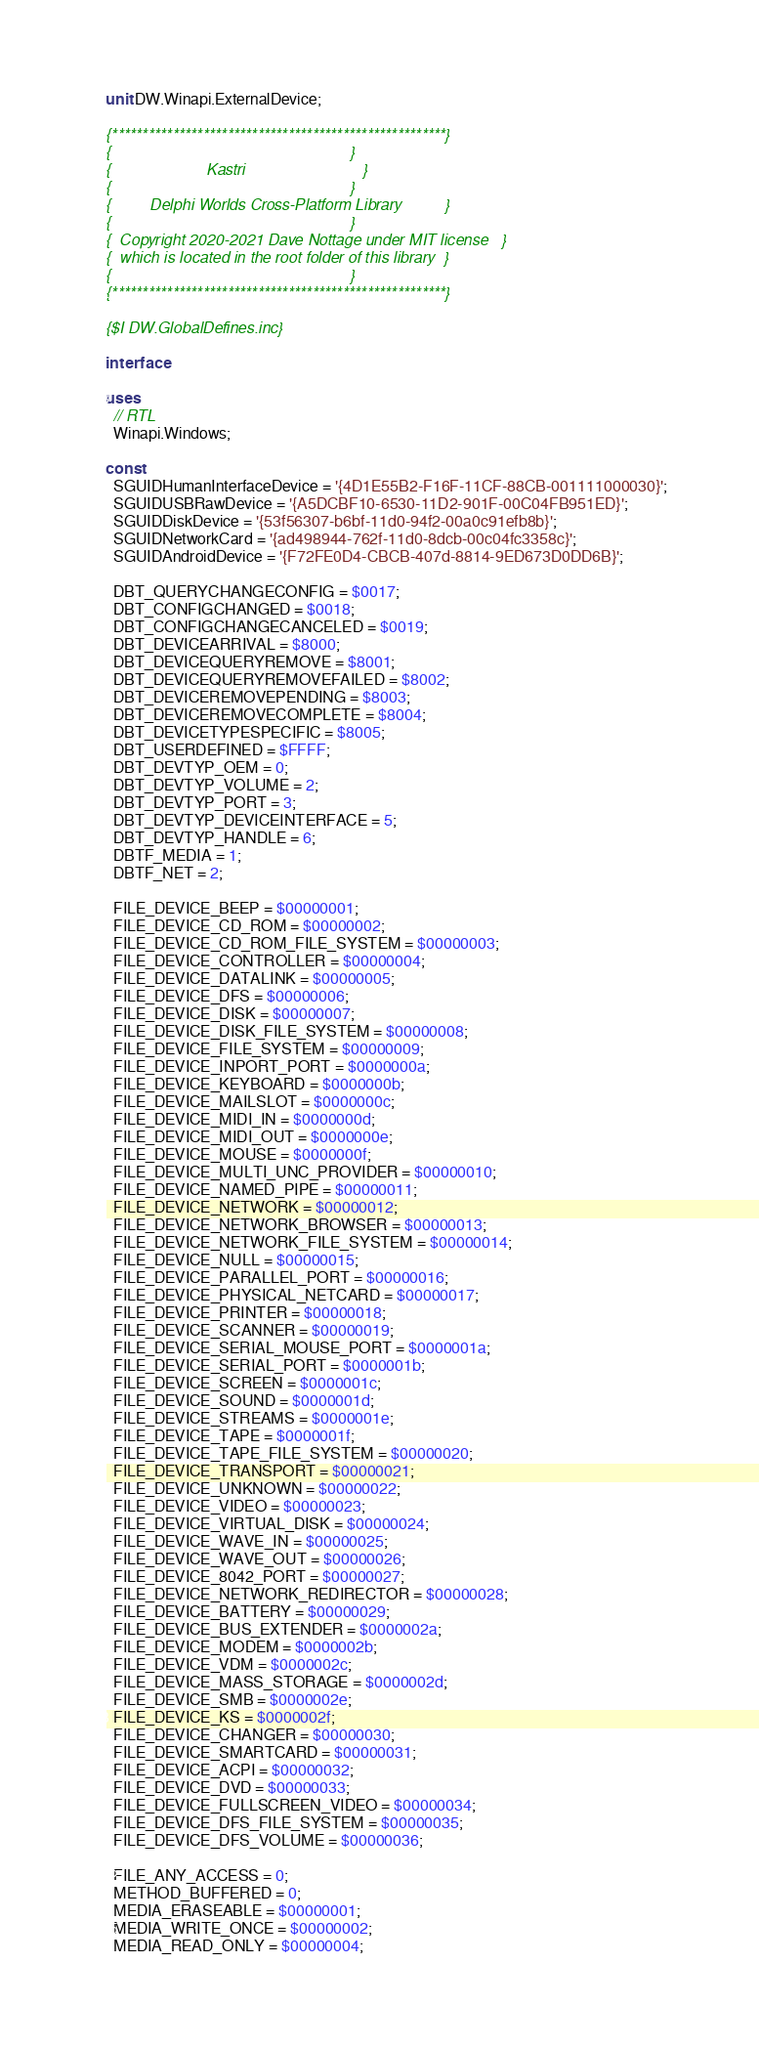<code> <loc_0><loc_0><loc_500><loc_500><_Pascal_>unit DW.Winapi.ExternalDevice;

{*******************************************************}
{                                                       }
{                      Kastri                           }
{                                                       }
{         Delphi Worlds Cross-Platform Library          }
{                                                       }
{  Copyright 2020-2021 Dave Nottage under MIT license   }
{  which is located in the root folder of this library  }
{                                                       }
{*******************************************************}

{$I DW.GlobalDefines.inc}

interface

uses
  // RTL
  Winapi.Windows;

const
  SGUIDHumanInterfaceDevice = '{4D1E55B2-F16F-11CF-88CB-001111000030}';
  SGUIDUSBRawDevice = '{A5DCBF10-6530-11D2-901F-00C04FB951ED}';
  SGUIDDiskDevice = '{53f56307-b6bf-11d0-94f2-00a0c91efb8b}';
  SGUIDNetworkCard = '{ad498944-762f-11d0-8dcb-00c04fc3358c}';
  SGUIDAndroidDevice = '{F72FE0D4-CBCB-407d-8814-9ED673D0DD6B}';

  DBT_QUERYCHANGECONFIG = $0017;
  DBT_CONFIGCHANGED = $0018;
  DBT_CONFIGCHANGECANCELED = $0019;
  DBT_DEVICEARRIVAL = $8000;
  DBT_DEVICEQUERYREMOVE = $8001;
  DBT_DEVICEQUERYREMOVEFAILED = $8002;
  DBT_DEVICEREMOVEPENDING = $8003;
  DBT_DEVICEREMOVECOMPLETE = $8004;
  DBT_DEVICETYPESPECIFIC = $8005;
  DBT_USERDEFINED = $FFFF;
  DBT_DEVTYP_OEM = 0;
  DBT_DEVTYP_VOLUME = 2;
  DBT_DEVTYP_PORT = 3;
  DBT_DEVTYP_DEVICEINTERFACE = 5;
  DBT_DEVTYP_HANDLE = 6;
  DBTF_MEDIA = 1;
  DBTF_NET = 2;

  FILE_DEVICE_BEEP = $00000001;
  FILE_DEVICE_CD_ROM = $00000002;
  FILE_DEVICE_CD_ROM_FILE_SYSTEM = $00000003;
  FILE_DEVICE_CONTROLLER = $00000004;
  FILE_DEVICE_DATALINK = $00000005;
  FILE_DEVICE_DFS = $00000006;
  FILE_DEVICE_DISK = $00000007;
  FILE_DEVICE_DISK_FILE_SYSTEM = $00000008;
  FILE_DEVICE_FILE_SYSTEM = $00000009;
  FILE_DEVICE_INPORT_PORT = $0000000a;
  FILE_DEVICE_KEYBOARD = $0000000b;
  FILE_DEVICE_MAILSLOT = $0000000c;
  FILE_DEVICE_MIDI_IN = $0000000d;
  FILE_DEVICE_MIDI_OUT = $0000000e;
  FILE_DEVICE_MOUSE = $0000000f;
  FILE_DEVICE_MULTI_UNC_PROVIDER = $00000010;
  FILE_DEVICE_NAMED_PIPE = $00000011;
  FILE_DEVICE_NETWORK = $00000012;
  FILE_DEVICE_NETWORK_BROWSER = $00000013;
  FILE_DEVICE_NETWORK_FILE_SYSTEM = $00000014;
  FILE_DEVICE_NULL = $00000015;
  FILE_DEVICE_PARALLEL_PORT = $00000016;
  FILE_DEVICE_PHYSICAL_NETCARD = $00000017;
  FILE_DEVICE_PRINTER = $00000018;
  FILE_DEVICE_SCANNER = $00000019;
  FILE_DEVICE_SERIAL_MOUSE_PORT = $0000001a;
  FILE_DEVICE_SERIAL_PORT = $0000001b;
  FILE_DEVICE_SCREEN = $0000001c;
  FILE_DEVICE_SOUND = $0000001d;
  FILE_DEVICE_STREAMS = $0000001e;
  FILE_DEVICE_TAPE = $0000001f;
  FILE_DEVICE_TAPE_FILE_SYSTEM = $00000020;
  FILE_DEVICE_TRANSPORT = $00000021;
  FILE_DEVICE_UNKNOWN = $00000022;
  FILE_DEVICE_VIDEO = $00000023;
  FILE_DEVICE_VIRTUAL_DISK = $00000024;
  FILE_DEVICE_WAVE_IN = $00000025;
  FILE_DEVICE_WAVE_OUT = $00000026;
  FILE_DEVICE_8042_PORT = $00000027;
  FILE_DEVICE_NETWORK_REDIRECTOR = $00000028;
  FILE_DEVICE_BATTERY = $00000029;
  FILE_DEVICE_BUS_EXTENDER = $0000002a;
  FILE_DEVICE_MODEM = $0000002b;
  FILE_DEVICE_VDM = $0000002c;
  FILE_DEVICE_MASS_STORAGE = $0000002d;
  FILE_DEVICE_SMB = $0000002e;
  FILE_DEVICE_KS = $0000002f;
  FILE_DEVICE_CHANGER = $00000030;
  FILE_DEVICE_SMARTCARD = $00000031;
  FILE_DEVICE_ACPI = $00000032;
  FILE_DEVICE_DVD = $00000033;
  FILE_DEVICE_FULLSCREEN_VIDEO = $00000034;
  FILE_DEVICE_DFS_FILE_SYSTEM = $00000035;
  FILE_DEVICE_DFS_VOLUME = $00000036;

  FILE_ANY_ACCESS = 0;
  METHOD_BUFFERED = 0;
  MEDIA_ERASEABLE = $00000001;
  MEDIA_WRITE_ONCE = $00000002;
  MEDIA_READ_ONLY = $00000004;</code> 